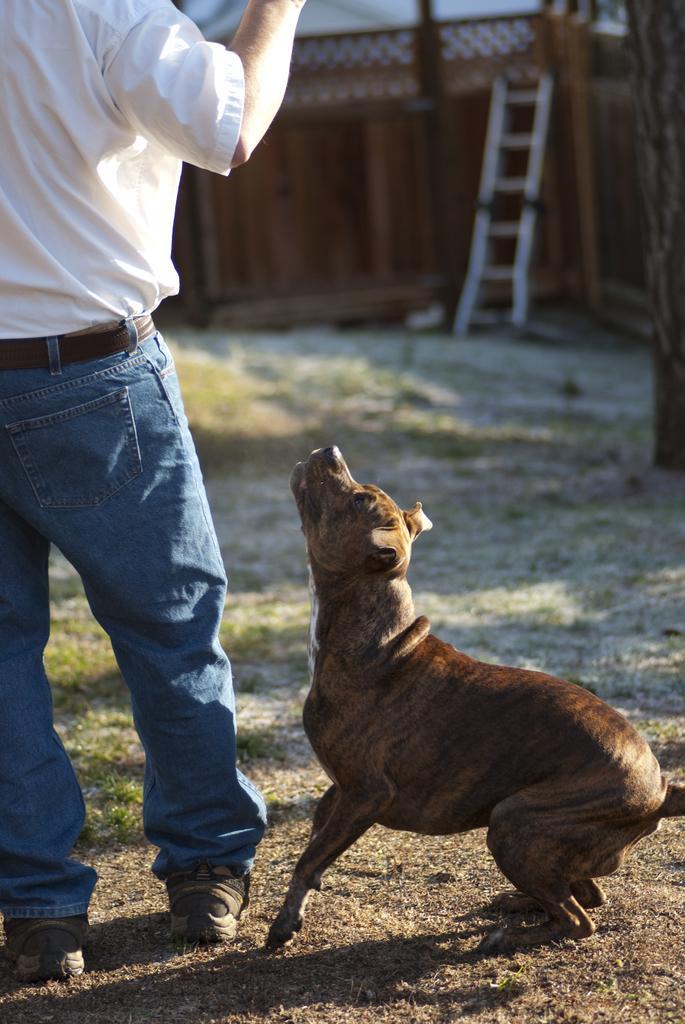How would you summarize this image in a sentence or two? In this image a person wearing a white dress is standing on the land having some grass. Beside the person there is a dog. A ladder is kept near the wooden fence. Right side there is a wooden trunk. 